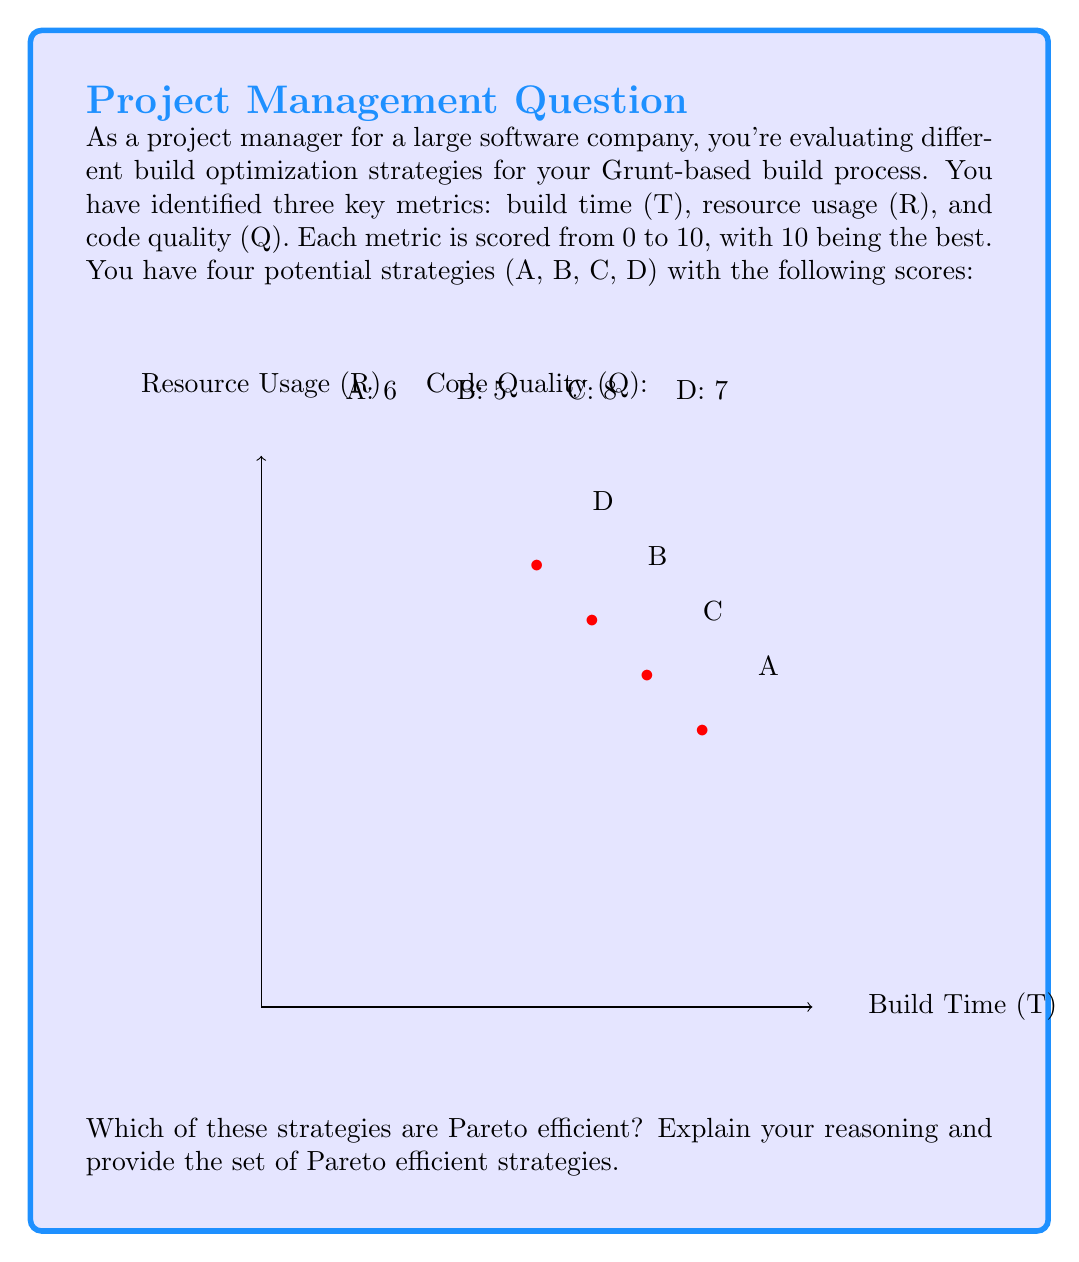Could you help me with this problem? To determine which strategies are Pareto efficient, we need to compare each strategy with every other strategy and check if it's dominated or not. A strategy is Pareto efficient if no other strategy is better in all metrics simultaneously.

Let's compare each strategy:

1. Strategy A (8,5,6):
   - Dominated by C (7,6,8) in all metrics
   - Not Pareto efficient

2. Strategy B (6,7,5):
   - Not dominated by any other strategy
   - Pareto efficient

3. Strategy C (7,6,8):
   - Not dominated by any other strategy
   - Pareto efficient

4. Strategy D (5,8,7):
   - Not dominated by any other strategy
   - Pareto efficient

To be more specific:
- B is better than A in T and R, but worse in Q
- C is better than A in all metrics
- D is better than A in R and Q, but worse in T
- C is better than B in T and Q, but worse in R
- D is better than B in R and Q, but worse in T
- D is better than C in R, but worse in T and Q

Therefore, strategies B, C, and D are Pareto efficient because no other strategy dominates them in all metrics simultaneously. Strategy A is not Pareto efficient because it is dominated by strategy C in all metrics.

The Pareto frontier in this case consists of strategies B, C, and D, as they represent the best trade-offs between build time, resource usage, and code quality.
Answer: {B, C, D} 